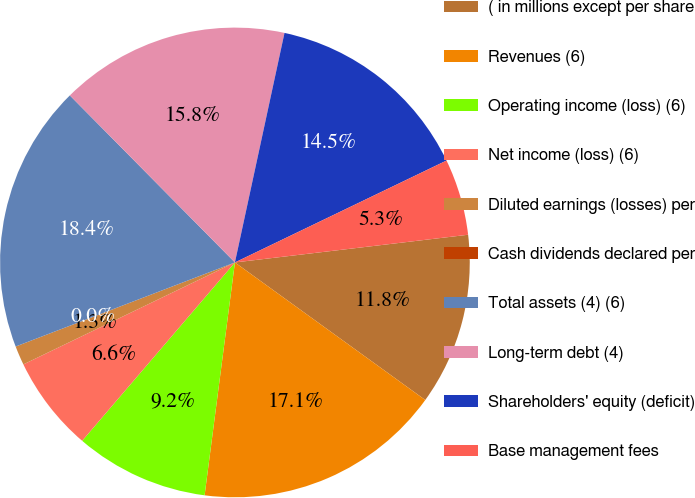Convert chart to OTSL. <chart><loc_0><loc_0><loc_500><loc_500><pie_chart><fcel>( in millions except per share<fcel>Revenues (6)<fcel>Operating income (loss) (6)<fcel>Net income (loss) (6)<fcel>Diluted earnings (losses) per<fcel>Cash dividends declared per<fcel>Total assets (4) (6)<fcel>Long-term debt (4)<fcel>Shareholders' equity (deficit)<fcel>Base management fees<nl><fcel>11.84%<fcel>17.1%<fcel>9.21%<fcel>6.58%<fcel>1.32%<fcel>0.0%<fcel>18.42%<fcel>15.79%<fcel>14.47%<fcel>5.26%<nl></chart> 